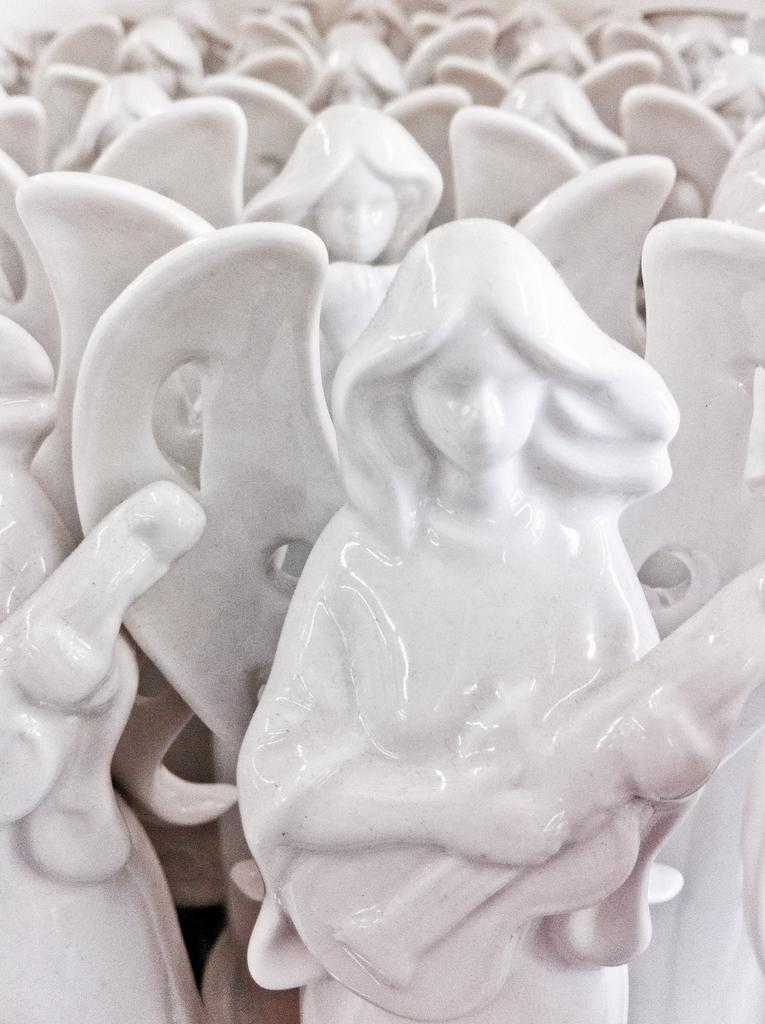What color are the statues in the image? The statues in the image are white. What are the statues holding in their hands? The statues are holding guitars. How many schools can be seen in the image? There are no schools present in the image; it features white color statues holding guitars. What type of arch is visible in the image? There is no arch present in the image. 